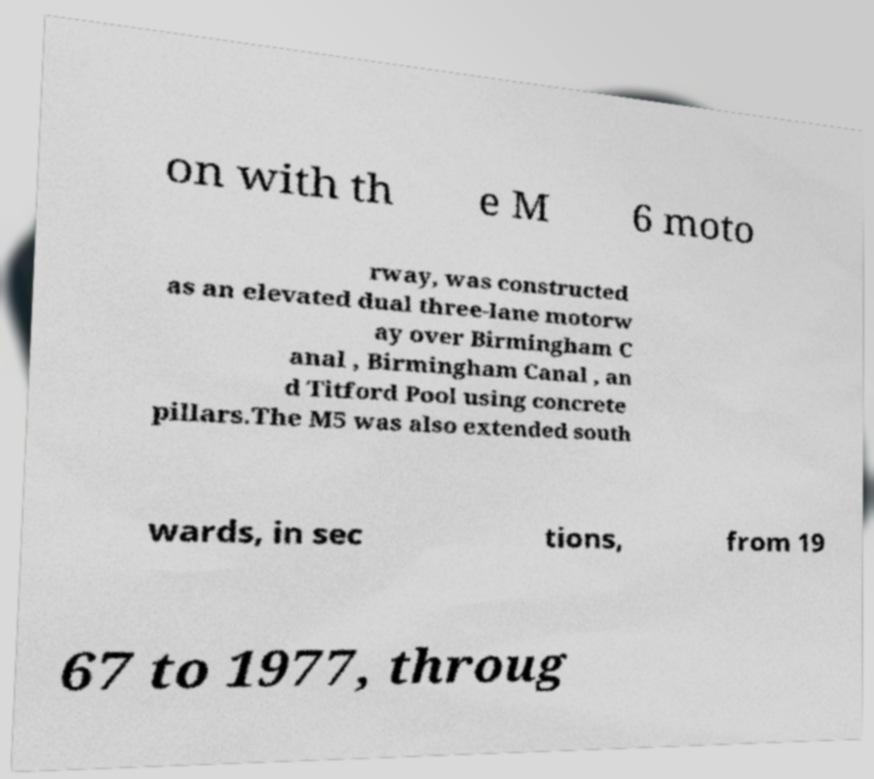Could you assist in decoding the text presented in this image and type it out clearly? on with th e M 6 moto rway, was constructed as an elevated dual three-lane motorw ay over Birmingham C anal , Birmingham Canal , an d Titford Pool using concrete pillars.The M5 was also extended south wards, in sec tions, from 19 67 to 1977, throug 